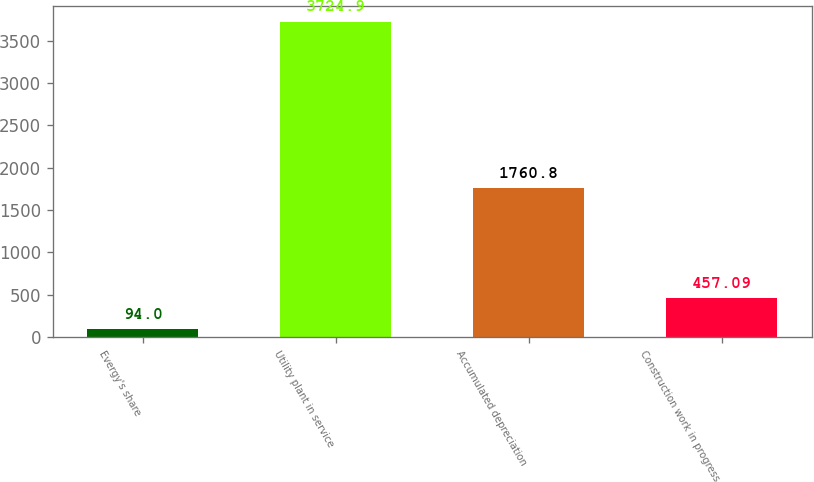Convert chart to OTSL. <chart><loc_0><loc_0><loc_500><loc_500><bar_chart><fcel>Evergy's share<fcel>Utility plant in service<fcel>Accumulated depreciation<fcel>Construction work in progress<nl><fcel>94<fcel>3724.9<fcel>1760.8<fcel>457.09<nl></chart> 